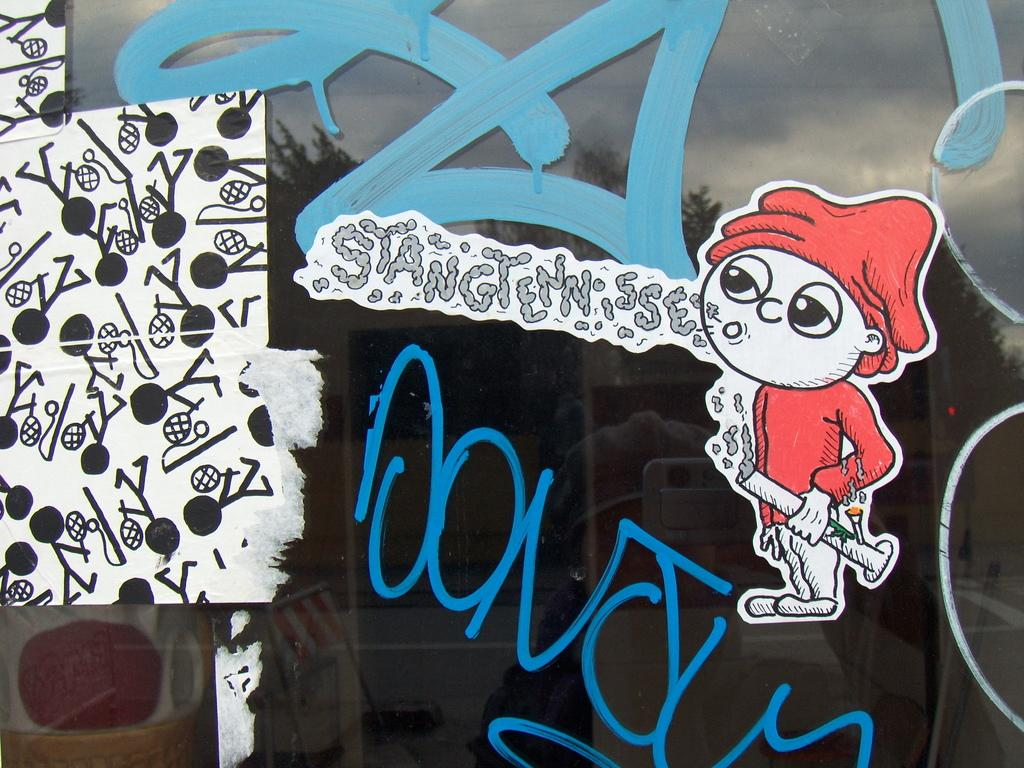What is depicted on the glass in the image? There is an art on the glass in the image. What degree of difficulty does the ball have in the milk in the image? There is no ball or milk present in the image; it only features art on a glass. 